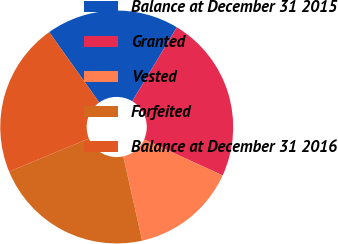Convert chart to OTSL. <chart><loc_0><loc_0><loc_500><loc_500><pie_chart><fcel>Balance at December 31 2015<fcel>Granted<fcel>Vested<fcel>Forfeited<fcel>Balance at December 31 2016<nl><fcel>18.48%<fcel>23.18%<fcel>14.68%<fcel>22.25%<fcel>21.41%<nl></chart> 